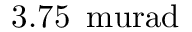<formula> <loc_0><loc_0><loc_500><loc_500>3 . 7 5 \, \ m u r a d</formula> 